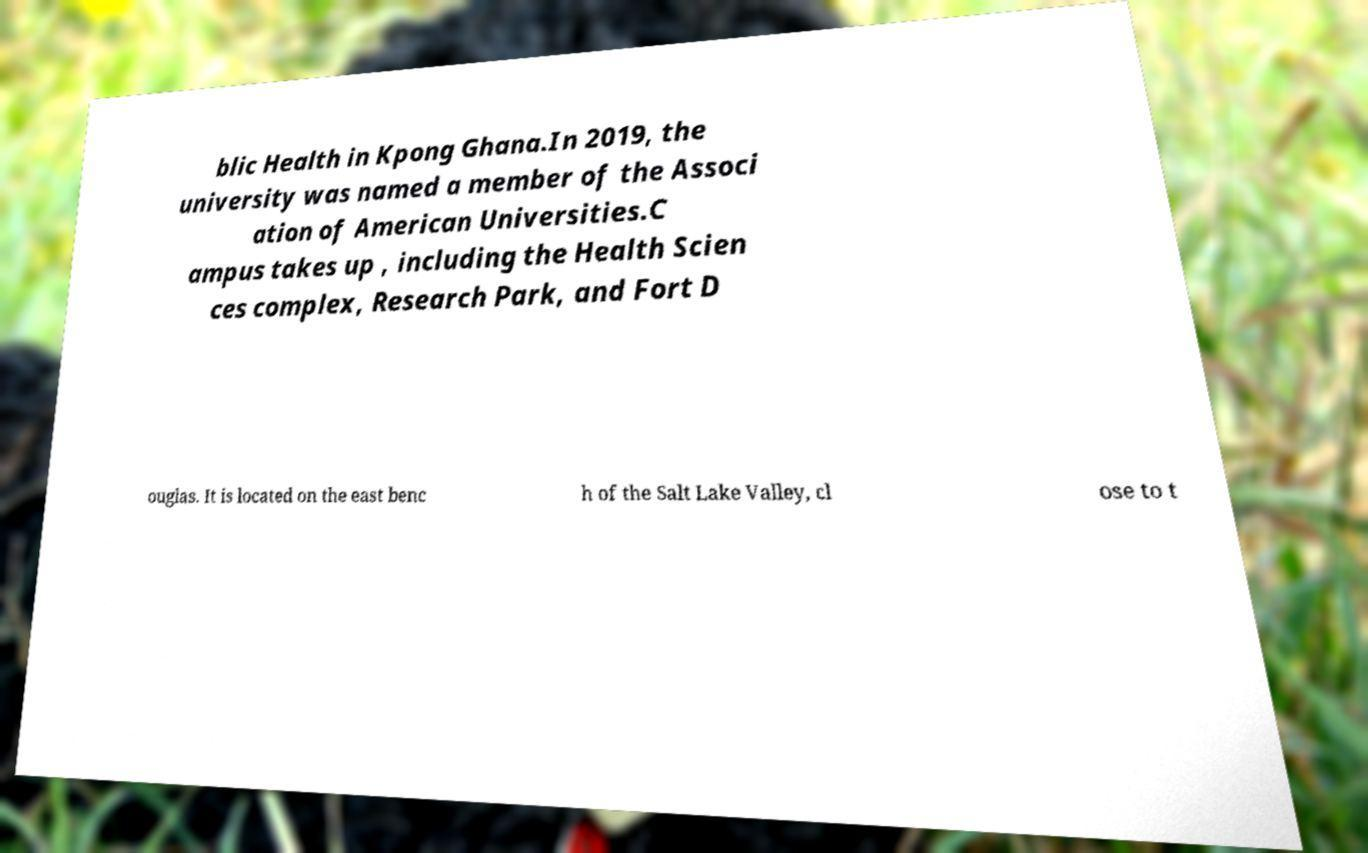Can you read and provide the text displayed in the image?This photo seems to have some interesting text. Can you extract and type it out for me? blic Health in Kpong Ghana.In 2019, the university was named a member of the Associ ation of American Universities.C ampus takes up , including the Health Scien ces complex, Research Park, and Fort D ouglas. It is located on the east benc h of the Salt Lake Valley, cl ose to t 